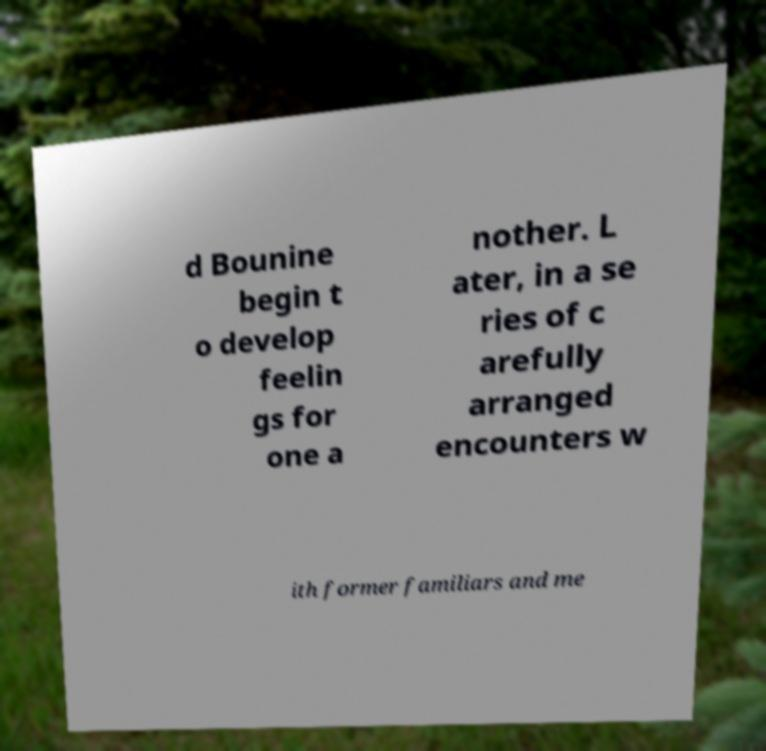Please read and relay the text visible in this image. What does it say? d Bounine begin t o develop feelin gs for one a nother. L ater, in a se ries of c arefully arranged encounters w ith former familiars and me 